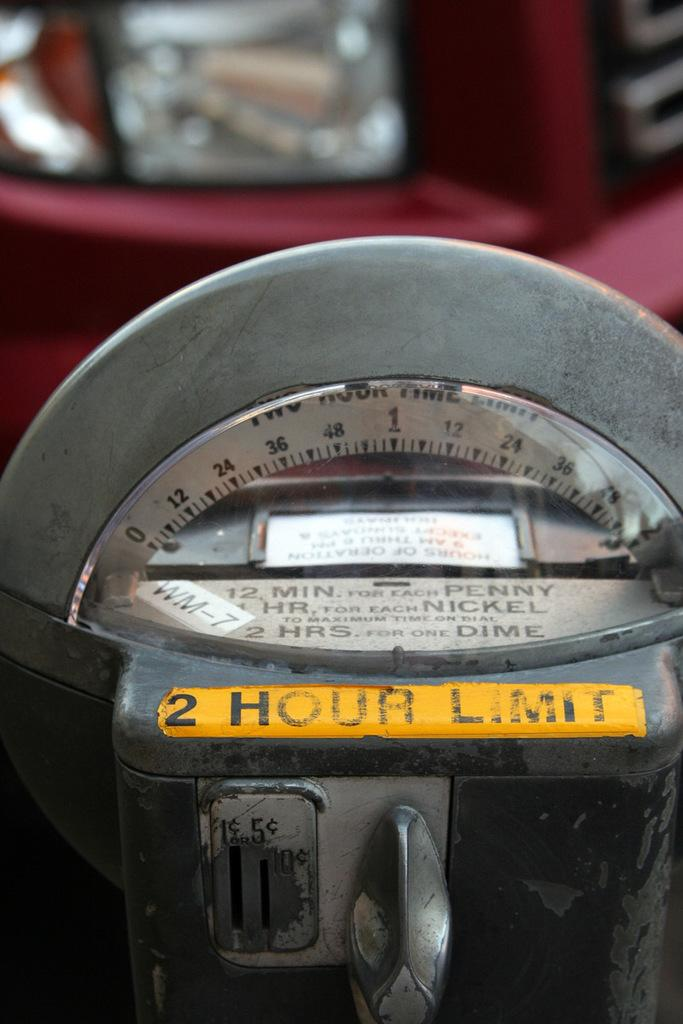<image>
Create a compact narrative representing the image presented. a meter with the number 2 on it 